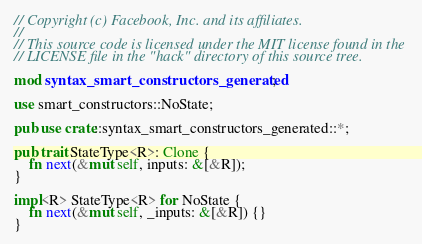Convert code to text. <code><loc_0><loc_0><loc_500><loc_500><_Rust_>// Copyright (c) Facebook, Inc. and its affiliates.
//
// This source code is licensed under the MIT license found in the
// LICENSE file in the "hack" directory of this source tree.

mod syntax_smart_constructors_generated;

use smart_constructors::NoState;

pub use crate::syntax_smart_constructors_generated::*;

pub trait StateType<R>: Clone {
    fn next(&mut self, inputs: &[&R]);
}

impl<R> StateType<R> for NoState {
    fn next(&mut self, _inputs: &[&R]) {}
}
</code> 